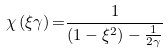<formula> <loc_0><loc_0><loc_500><loc_500>\chi \left ( \xi \gamma \right ) { = } \frac { 1 } { \left ( 1 - \xi ^ { 2 } \right ) - \frac { 1 } { 2 \gamma } }</formula> 